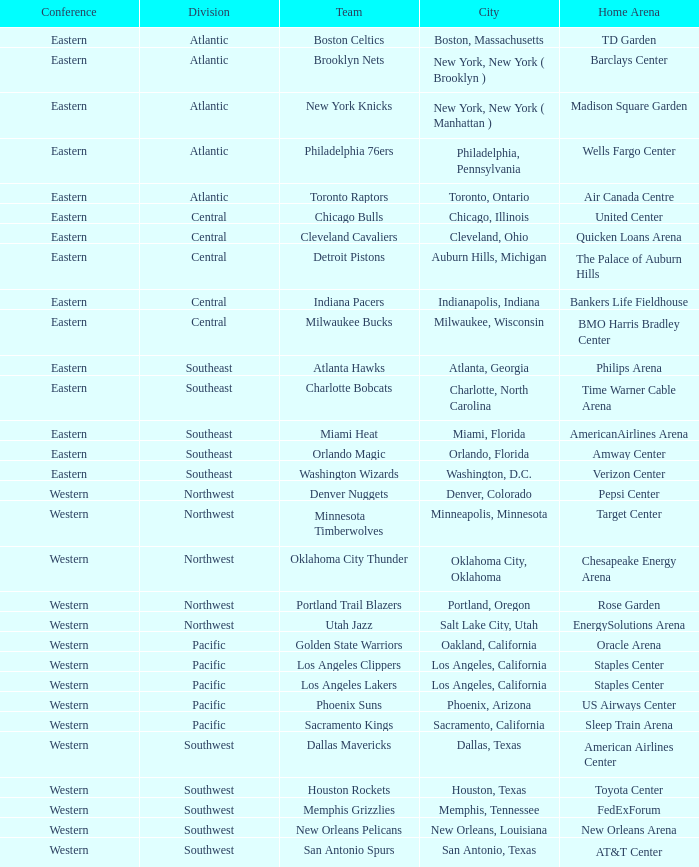Which city includes Barclays Center? New York, New York ( Brooklyn ). 